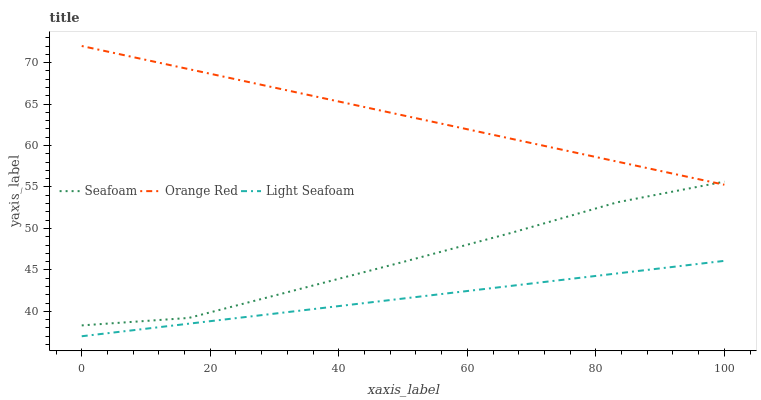Does Light Seafoam have the minimum area under the curve?
Answer yes or no. Yes. Does Orange Red have the maximum area under the curve?
Answer yes or no. Yes. Does Seafoam have the minimum area under the curve?
Answer yes or no. No. Does Seafoam have the maximum area under the curve?
Answer yes or no. No. Is Light Seafoam the smoothest?
Answer yes or no. Yes. Is Seafoam the roughest?
Answer yes or no. Yes. Is Orange Red the smoothest?
Answer yes or no. No. Is Orange Red the roughest?
Answer yes or no. No. Does Light Seafoam have the lowest value?
Answer yes or no. Yes. Does Seafoam have the lowest value?
Answer yes or no. No. Does Orange Red have the highest value?
Answer yes or no. Yes. Does Seafoam have the highest value?
Answer yes or no. No. Is Light Seafoam less than Orange Red?
Answer yes or no. Yes. Is Orange Red greater than Light Seafoam?
Answer yes or no. Yes. Does Seafoam intersect Orange Red?
Answer yes or no. Yes. Is Seafoam less than Orange Red?
Answer yes or no. No. Is Seafoam greater than Orange Red?
Answer yes or no. No. Does Light Seafoam intersect Orange Red?
Answer yes or no. No. 